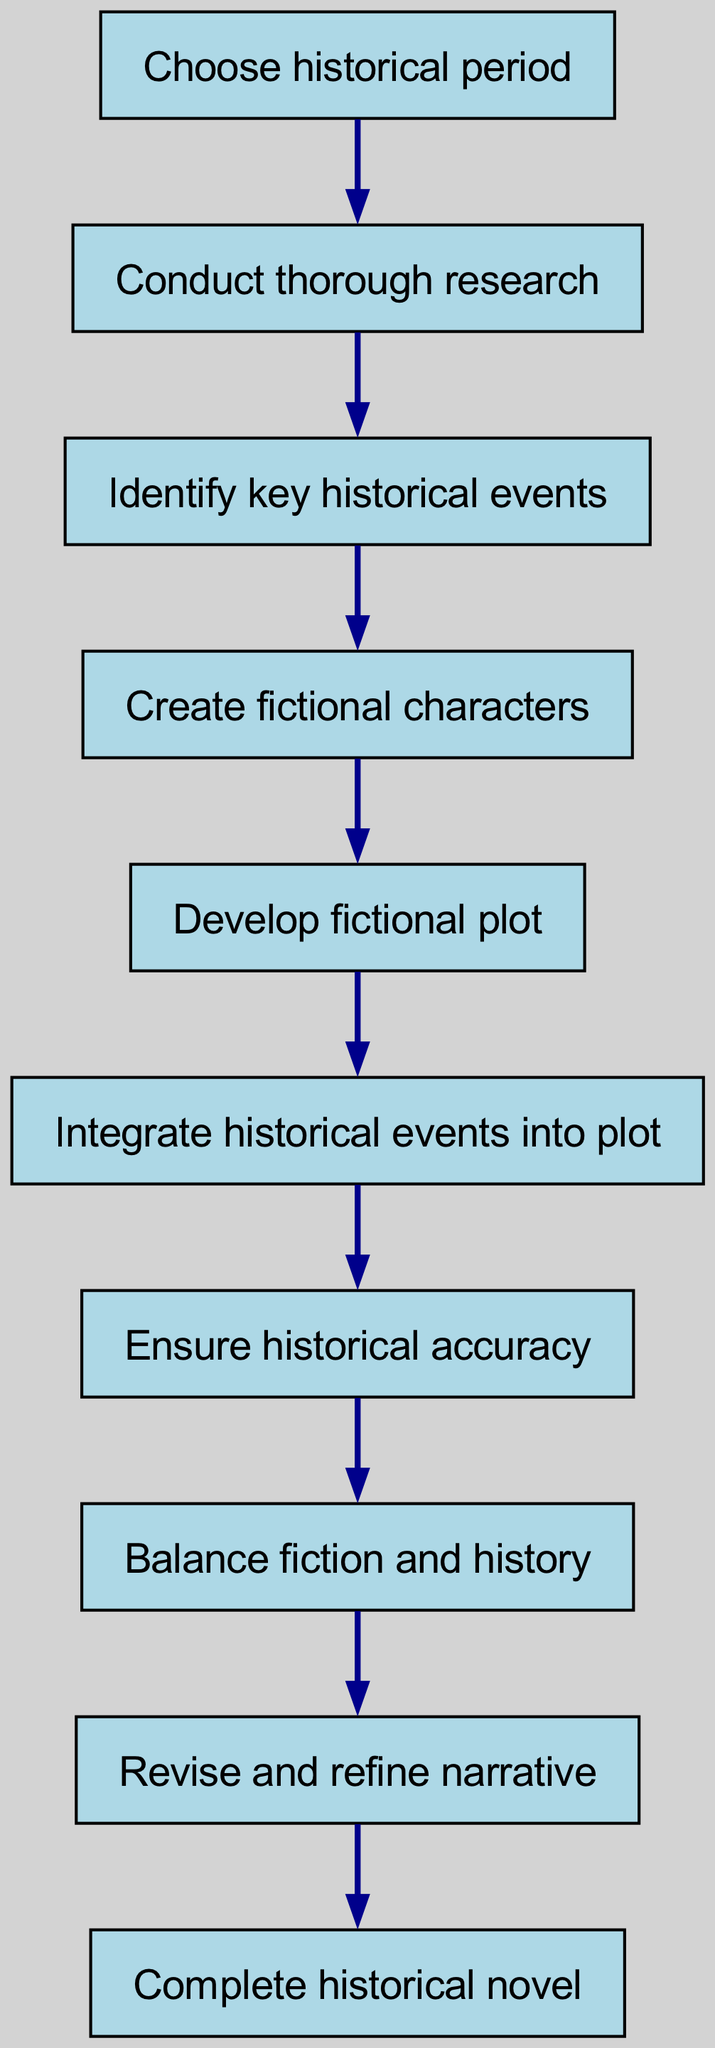What is the first step in the process? The first node in the diagram is labeled "Choose historical period," indicating it is the starting point of the process.
Answer: Choose historical period How many steps are in this process? Counting the nodes from "Choose historical period" to "Complete historical novel," there are a total of 9 steps in the process.
Answer: 9 What step follows 'Research'? The diagram shows an arrow leading from "Conduct thorough research" to "Identify key historical events," indicating that this is the next step after research.
Answer: Identify key historical events What is the last step in the flow? The last node in the diagram is labeled "Complete historical novel," which signifies the endpoint of the entire process.
Answer: Complete historical novel Which step involves creating fictional characters? The node "Create fictional characters" is a distinct step in the sequence that specifically mentions character creation, positioned after identifying historical events.
Answer: Create fictional characters Which two steps are directly connected to 'Ensure historical accuracy'? The flow chart shows that 'Ensure historical accuracy' is followed by 'Balance fiction and history' and preceded by 'Integrate historical events into plot,' connecting it to both these steps.
Answer: Integrate historical events into plot, Balance fiction and history What is the relationship between 'Balance fiction and history' and 'Revise and refine narrative'? An arrow is depicted from "Balance fiction and history" to "Revise and refine narrative," indicating that balancing these elements leads to the subsequent step.
Answer: Leads to How many connections are there between steps in this process? Each step in the flow chart is linked by arrows to the next step, and there are a total of 8 connections present between the 9 steps.
Answer: 8 What is the purpose of the 'Revise and refine narrative' step? The purpose of this step, while not explicitly stated, is implied to be the final adjustment of the narrative before reaching completion, following the need to integrate, ensure accuracy, and balance the elements.
Answer: Final adjustments 